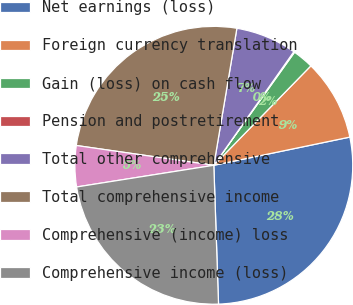Convert chart. <chart><loc_0><loc_0><loc_500><loc_500><pie_chart><fcel>Net earnings (loss)<fcel>Foreign currency translation<fcel>Gain (loss) on cash flow<fcel>Pension and postretirement<fcel>Total other comprehensive<fcel>Total comprehensive income<fcel>Comprehensive (income) loss<fcel>Comprehensive income (loss)<nl><fcel>27.71%<fcel>9.44%<fcel>2.44%<fcel>0.1%<fcel>7.11%<fcel>25.38%<fcel>4.77%<fcel>23.04%<nl></chart> 